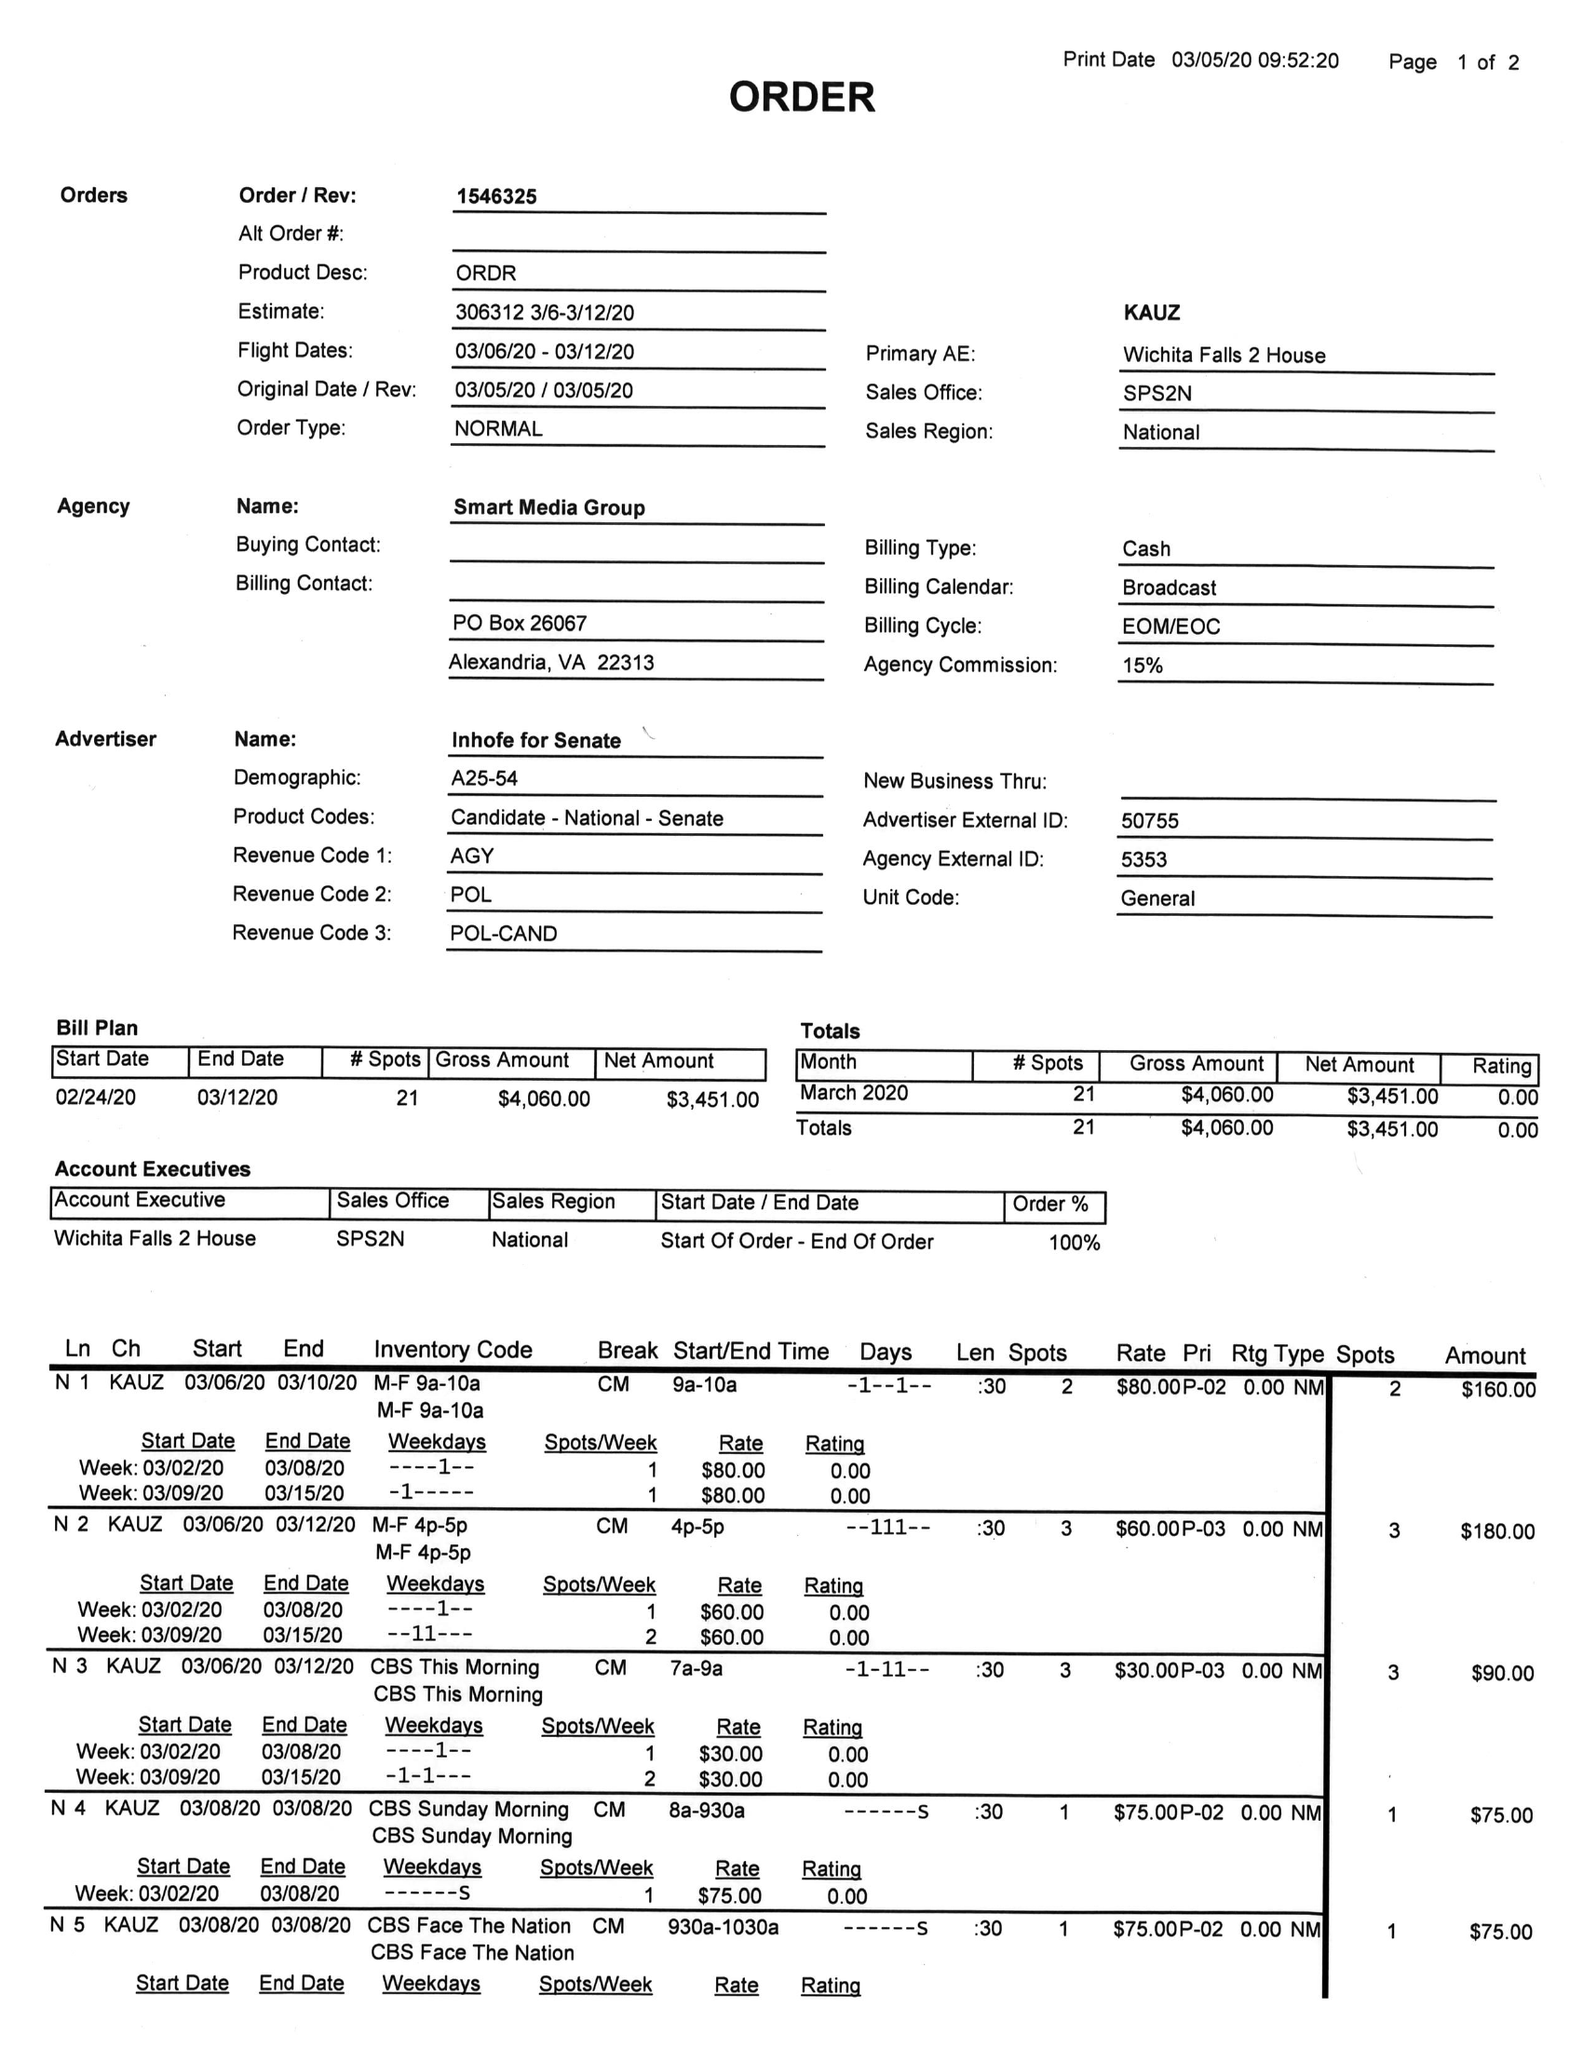What is the value for the flight_to?
Answer the question using a single word or phrase. 03/12/20 